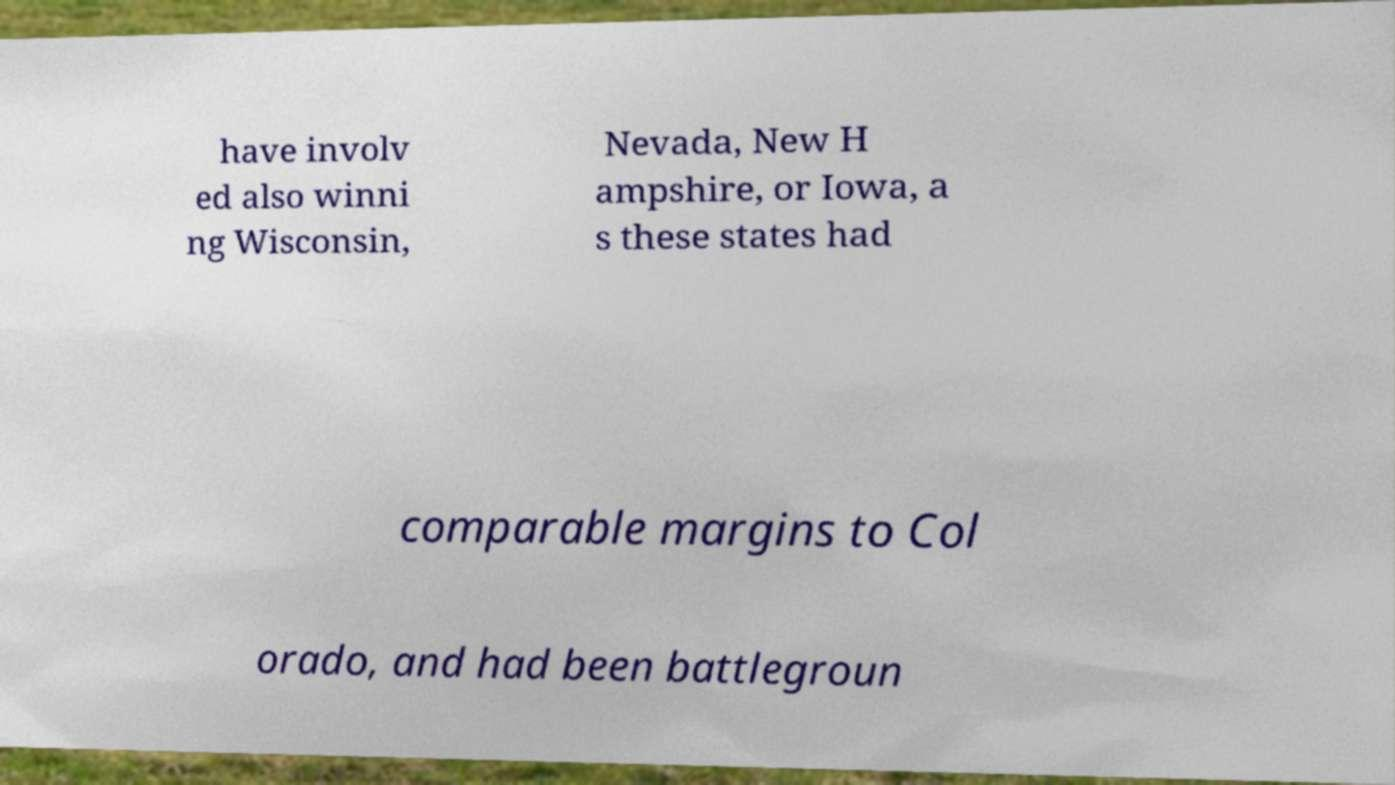For documentation purposes, I need the text within this image transcribed. Could you provide that? have involv ed also winni ng Wisconsin, Nevada, New H ampshire, or Iowa, a s these states had comparable margins to Col orado, and had been battlegroun 